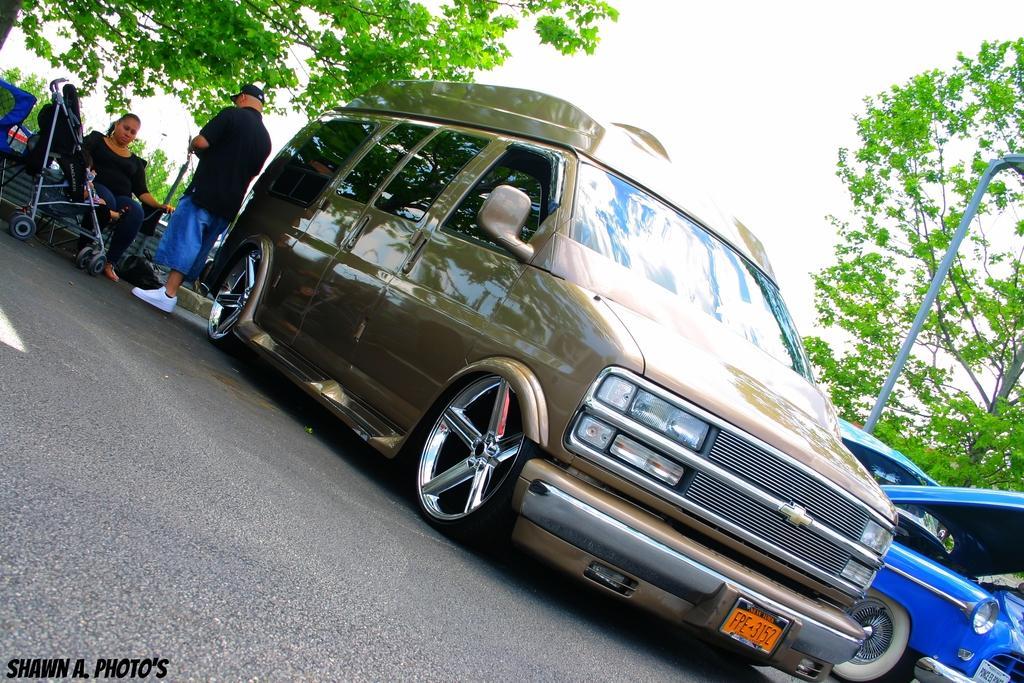In one or two sentences, can you explain what this image depicts? This is the car on this road, left side a woman is sitting and a man is standing. There are trees. 